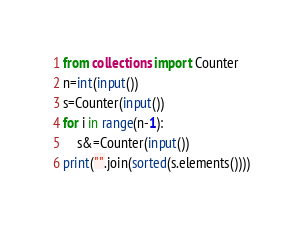Convert code to text. <code><loc_0><loc_0><loc_500><loc_500><_Python_>from collections import Counter
n=int(input())
s=Counter(input())
for i in range(n-1):
    s&=Counter(input())
print("".join(sorted(s.elements())))</code> 